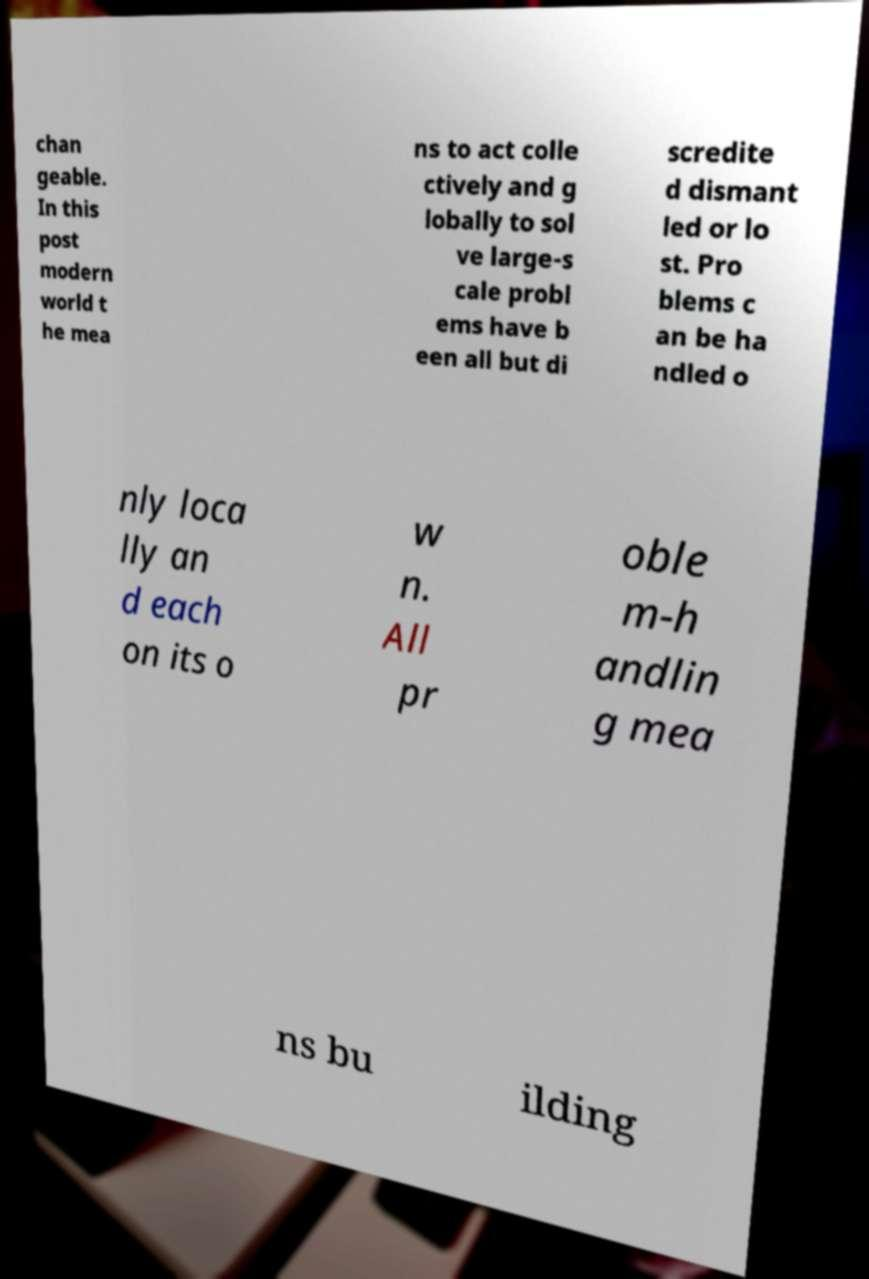I need the written content from this picture converted into text. Can you do that? chan geable. In this post modern world t he mea ns to act colle ctively and g lobally to sol ve large-s cale probl ems have b een all but di scredite d dismant led or lo st. Pro blems c an be ha ndled o nly loca lly an d each on its o w n. All pr oble m-h andlin g mea ns bu ilding 